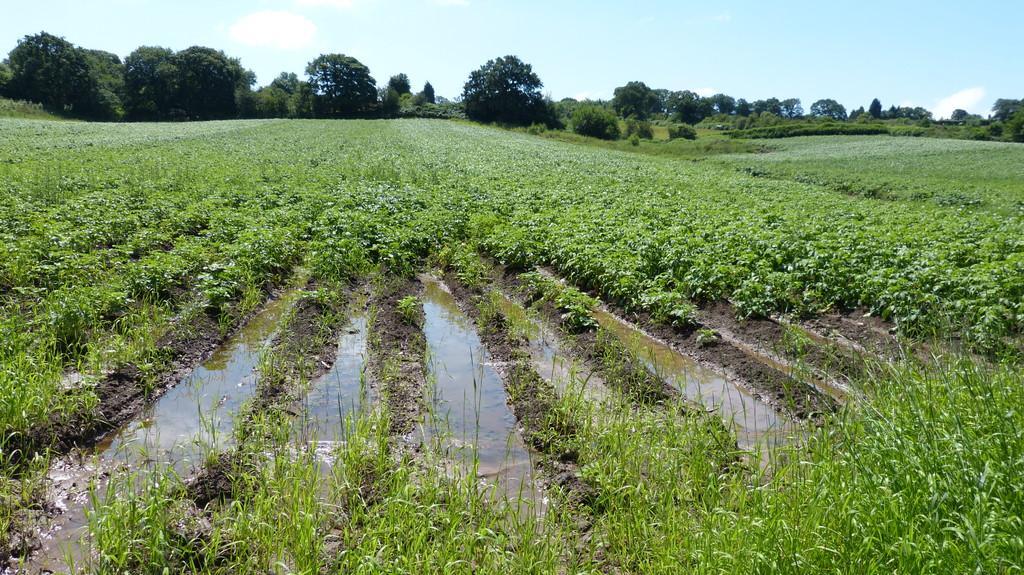In one or two sentences, can you explain what this image depicts? In this image there are plants on the left and right corner. There is water in the middle. There are trees in the background. And there is sky at the top. 